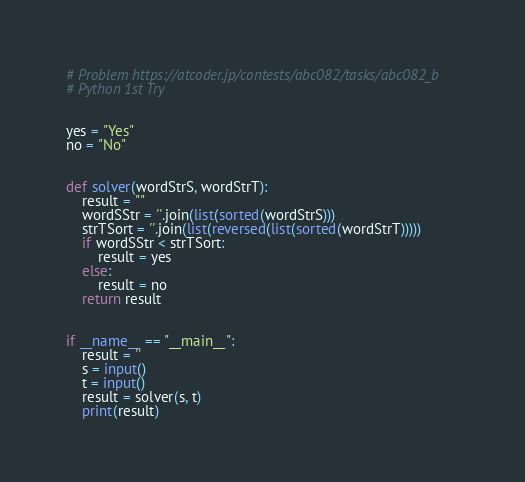Convert code to text. <code><loc_0><loc_0><loc_500><loc_500><_Python_># Problem https://atcoder.jp/contests/abc082/tasks/abc082_b
# Python 1st Try


yes = "Yes"
no = "No"


def solver(wordStrS, wordStrT):
    result = ""
    wordSStr = ''.join(list(sorted(wordStrS)))
    strTSort = ''.join(list(reversed(list(sorted(wordStrT)))))
    if wordSStr < strTSort:
        result = yes
    else:
        result = no
    return result


if __name__ == "__main__":
    result = ''
    s = input()
    t = input()
    result = solver(s, t)
    print(result)
</code> 